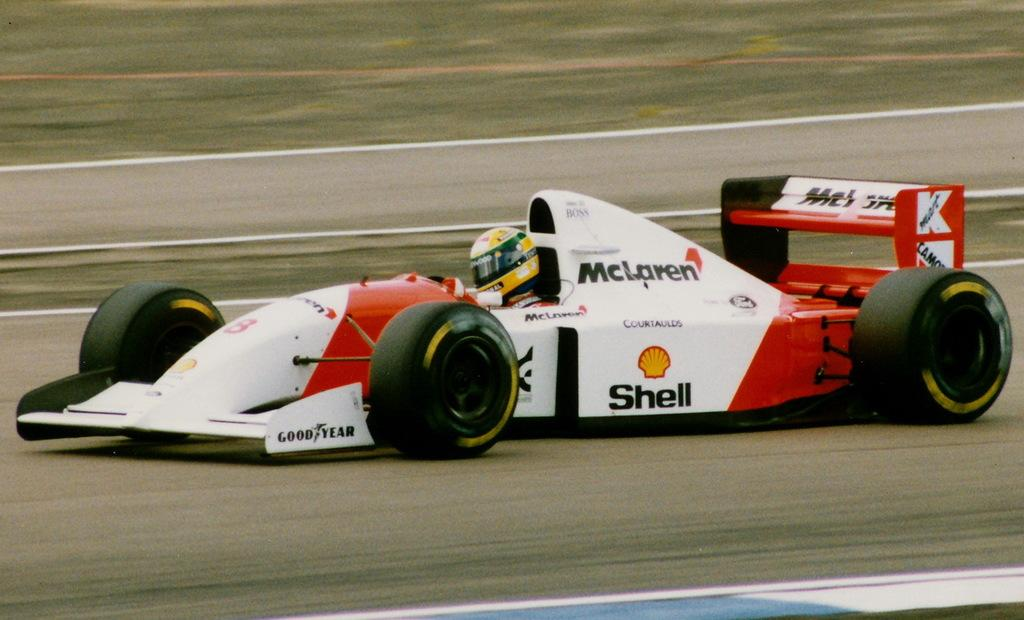<image>
Summarize the visual content of the image. A red and white race car sponsored by Shell on the race track with the driver inside. 